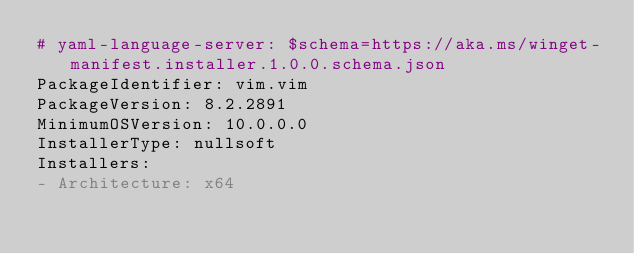<code> <loc_0><loc_0><loc_500><loc_500><_YAML_># yaml-language-server: $schema=https://aka.ms/winget-manifest.installer.1.0.0.schema.json
PackageIdentifier: vim.vim
PackageVersion: 8.2.2891
MinimumOSVersion: 10.0.0.0
InstallerType: nullsoft
Installers:
- Architecture: x64</code> 